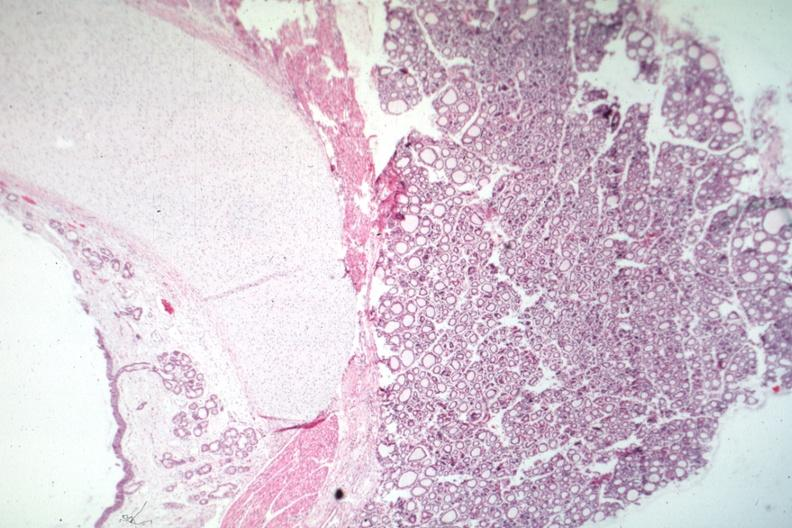what is present?
Answer the question using a single word or phrase. Normal immature infant 